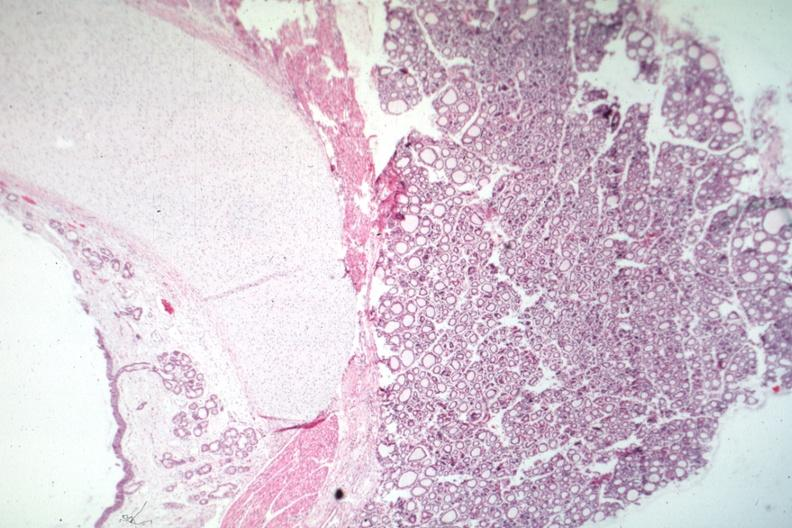what is present?
Answer the question using a single word or phrase. Normal immature infant 